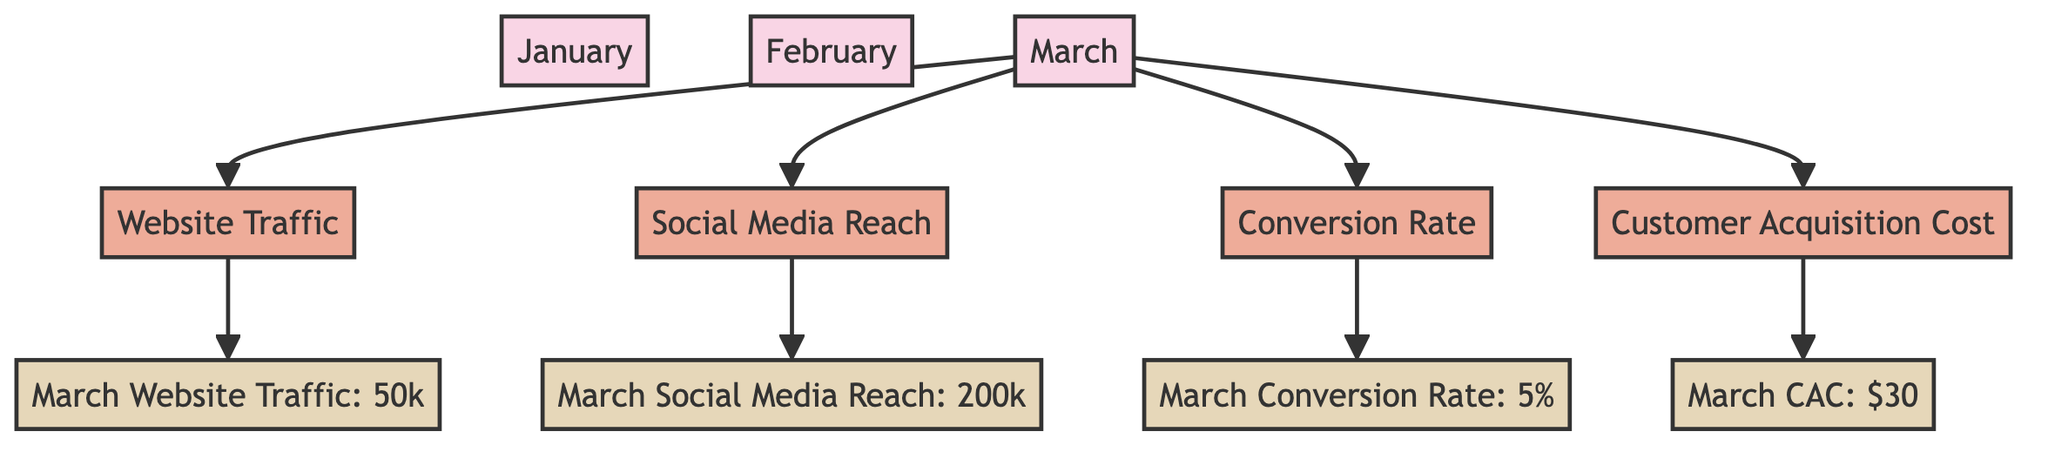What are the four KPIs shown for March? The diagram lists four KPIs branching from the March campaign node: Website Traffic, Social Media Reach, Conversion Rate, and Customer Acquisition Cost. These are connected directly to the March node indicating they are part of the performance metrics for that month.
Answer: Website Traffic, Social Media Reach, Conversion Rate, Customer Acquisition Cost What was the Website Traffic for March? The metric node directly connected to the Website Traffic KPI lists the data for March as 50k. This means that in terms of numerical value, the website traffic for March was 50,000.
Answer: 50k How much was the Customer Acquisition Cost in March? By following the path from the Customer Acquisition Cost KPI, we see a metric node that specifies the value as $30. This information clearly indicates the financial aspect related to customer acquisition in that month.
Answer: $30 Which month shows a breakdown of campaign performance? The only month represented in the diagram with a breakdown of performance metrics and KPIs is March, as indicated by its direct connection to multiple KPI nodes. The structure implies that only March’s performance is illustrated in this detail.
Answer: March How many KPIs are connected to the March campaign? The diagram presents four individual KPI nodes that are connected to the March campaign node, which indicates the extent of performance analysis for that month. Therefore, the count of KPIs is four.
Answer: Four What is the Conversion Rate for March? As indicated by the metric node for Conversion Rate directly linked to March, the value provided is 5%. This percentage reflects the efficiency or success of the marketing efforts for that period.
Answer: 5% 